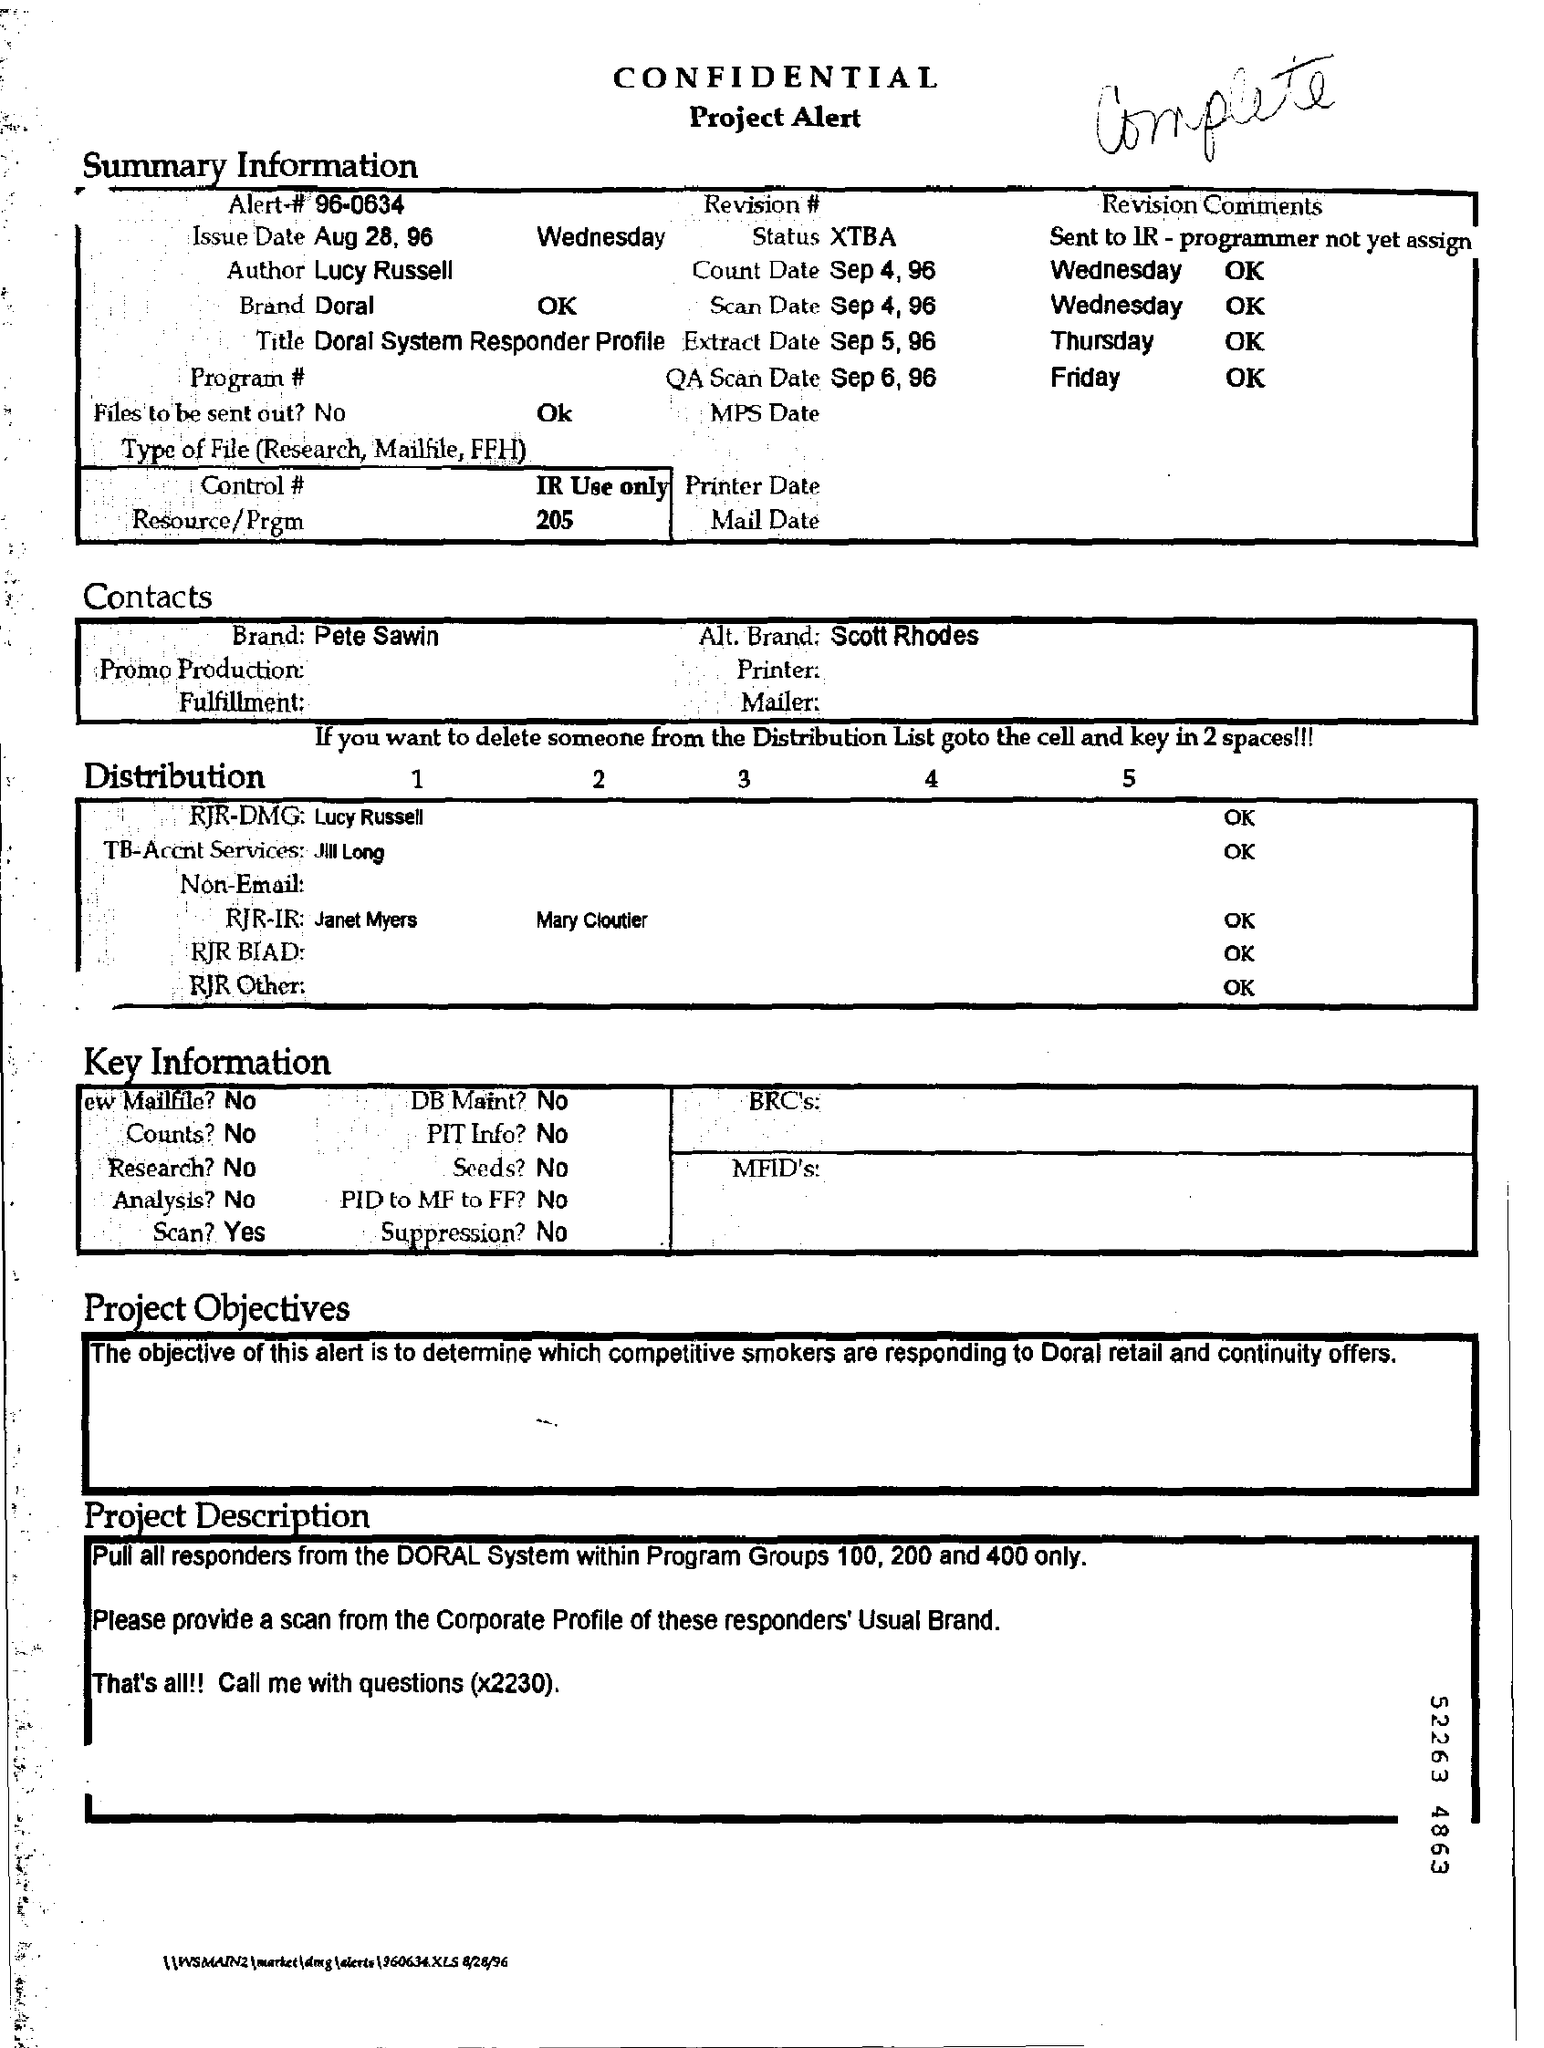What is written by hand on top of the page?
Keep it short and to the point. Complete. What is Alert#?
Your answer should be very brief. 96-0634. 